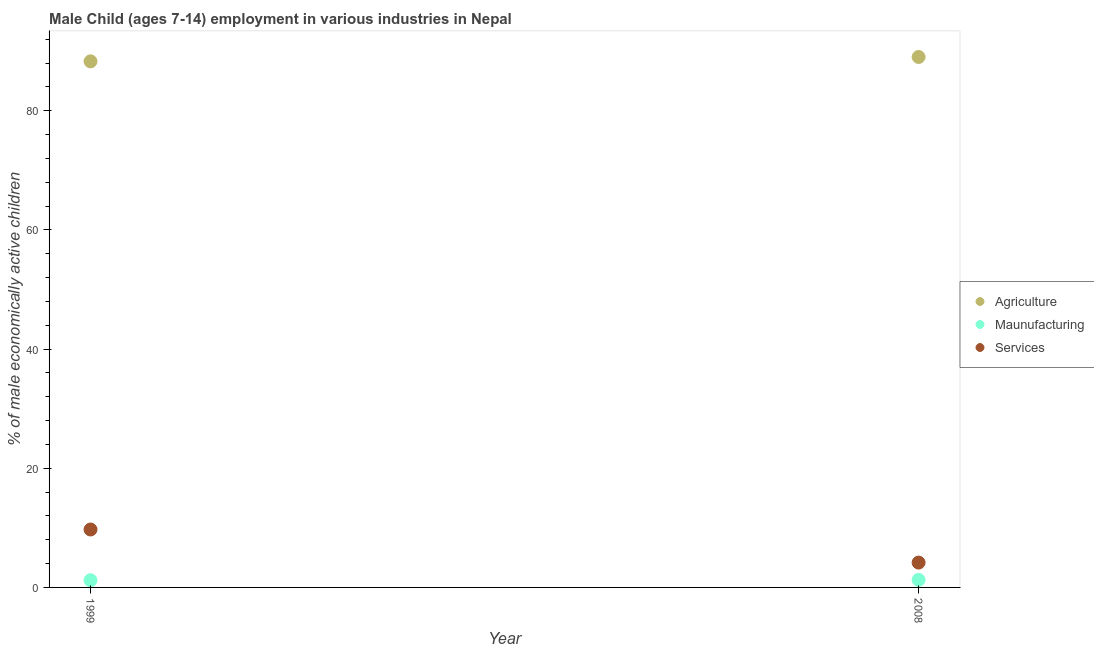Is the number of dotlines equal to the number of legend labels?
Offer a very short reply. Yes. What is the percentage of economically active children in manufacturing in 1999?
Give a very brief answer. 1.2. Across all years, what is the maximum percentage of economically active children in manufacturing?
Ensure brevity in your answer.  1.27. Across all years, what is the minimum percentage of economically active children in agriculture?
Offer a terse response. 88.3. In which year was the percentage of economically active children in agriculture minimum?
Provide a succinct answer. 1999. What is the total percentage of economically active children in manufacturing in the graph?
Your answer should be compact. 2.47. What is the difference between the percentage of economically active children in manufacturing in 1999 and that in 2008?
Give a very brief answer. -0.07. What is the difference between the percentage of economically active children in manufacturing in 1999 and the percentage of economically active children in agriculture in 2008?
Provide a succinct answer. -87.83. What is the average percentage of economically active children in manufacturing per year?
Give a very brief answer. 1.24. In the year 2008, what is the difference between the percentage of economically active children in agriculture and percentage of economically active children in services?
Offer a very short reply. 84.86. In how many years, is the percentage of economically active children in agriculture greater than 88 %?
Offer a terse response. 2. What is the ratio of the percentage of economically active children in services in 1999 to that in 2008?
Offer a very short reply. 2.33. Is the percentage of economically active children in services in 1999 less than that in 2008?
Provide a short and direct response. No. In how many years, is the percentage of economically active children in agriculture greater than the average percentage of economically active children in agriculture taken over all years?
Offer a terse response. 1. Is it the case that in every year, the sum of the percentage of economically active children in agriculture and percentage of economically active children in manufacturing is greater than the percentage of economically active children in services?
Your response must be concise. Yes. Does the percentage of economically active children in services monotonically increase over the years?
Provide a short and direct response. No. Is the percentage of economically active children in services strictly less than the percentage of economically active children in manufacturing over the years?
Provide a short and direct response. No. How many years are there in the graph?
Offer a terse response. 2. What is the difference between two consecutive major ticks on the Y-axis?
Offer a terse response. 20. Are the values on the major ticks of Y-axis written in scientific E-notation?
Your response must be concise. No. Does the graph contain any zero values?
Provide a succinct answer. No. What is the title of the graph?
Provide a succinct answer. Male Child (ages 7-14) employment in various industries in Nepal. What is the label or title of the X-axis?
Your answer should be very brief. Year. What is the label or title of the Y-axis?
Keep it short and to the point. % of male economically active children. What is the % of male economically active children in Agriculture in 1999?
Keep it short and to the point. 88.3. What is the % of male economically active children in Maunufacturing in 1999?
Give a very brief answer. 1.2. What is the % of male economically active children in Services in 1999?
Provide a succinct answer. 9.72. What is the % of male economically active children of Agriculture in 2008?
Keep it short and to the point. 89.03. What is the % of male economically active children of Maunufacturing in 2008?
Your answer should be compact. 1.27. What is the % of male economically active children of Services in 2008?
Provide a short and direct response. 4.17. Across all years, what is the maximum % of male economically active children of Agriculture?
Your answer should be compact. 89.03. Across all years, what is the maximum % of male economically active children in Maunufacturing?
Offer a terse response. 1.27. Across all years, what is the maximum % of male economically active children in Services?
Offer a terse response. 9.72. Across all years, what is the minimum % of male economically active children in Agriculture?
Ensure brevity in your answer.  88.3. Across all years, what is the minimum % of male economically active children of Maunufacturing?
Give a very brief answer. 1.2. Across all years, what is the minimum % of male economically active children in Services?
Provide a short and direct response. 4.17. What is the total % of male economically active children of Agriculture in the graph?
Keep it short and to the point. 177.33. What is the total % of male economically active children of Maunufacturing in the graph?
Give a very brief answer. 2.47. What is the total % of male economically active children in Services in the graph?
Make the answer very short. 13.89. What is the difference between the % of male economically active children in Agriculture in 1999 and that in 2008?
Ensure brevity in your answer.  -0.73. What is the difference between the % of male economically active children in Maunufacturing in 1999 and that in 2008?
Ensure brevity in your answer.  -0.07. What is the difference between the % of male economically active children in Services in 1999 and that in 2008?
Give a very brief answer. 5.55. What is the difference between the % of male economically active children in Agriculture in 1999 and the % of male economically active children in Maunufacturing in 2008?
Offer a terse response. 87.03. What is the difference between the % of male economically active children in Agriculture in 1999 and the % of male economically active children in Services in 2008?
Give a very brief answer. 84.13. What is the difference between the % of male economically active children of Maunufacturing in 1999 and the % of male economically active children of Services in 2008?
Make the answer very short. -2.97. What is the average % of male economically active children of Agriculture per year?
Give a very brief answer. 88.67. What is the average % of male economically active children of Maunufacturing per year?
Make the answer very short. 1.24. What is the average % of male economically active children of Services per year?
Provide a short and direct response. 6.95. In the year 1999, what is the difference between the % of male economically active children of Agriculture and % of male economically active children of Maunufacturing?
Your response must be concise. 87.1. In the year 1999, what is the difference between the % of male economically active children in Agriculture and % of male economically active children in Services?
Make the answer very short. 78.58. In the year 1999, what is the difference between the % of male economically active children of Maunufacturing and % of male economically active children of Services?
Provide a succinct answer. -8.52. In the year 2008, what is the difference between the % of male economically active children in Agriculture and % of male economically active children in Maunufacturing?
Give a very brief answer. 87.76. In the year 2008, what is the difference between the % of male economically active children in Agriculture and % of male economically active children in Services?
Your answer should be compact. 84.86. What is the ratio of the % of male economically active children of Maunufacturing in 1999 to that in 2008?
Your answer should be very brief. 0.95. What is the ratio of the % of male economically active children in Services in 1999 to that in 2008?
Provide a succinct answer. 2.33. What is the difference between the highest and the second highest % of male economically active children in Agriculture?
Provide a succinct answer. 0.73. What is the difference between the highest and the second highest % of male economically active children of Maunufacturing?
Your answer should be compact. 0.07. What is the difference between the highest and the second highest % of male economically active children of Services?
Provide a succinct answer. 5.55. What is the difference between the highest and the lowest % of male economically active children in Agriculture?
Your answer should be compact. 0.73. What is the difference between the highest and the lowest % of male economically active children in Maunufacturing?
Offer a terse response. 0.07. What is the difference between the highest and the lowest % of male economically active children in Services?
Provide a short and direct response. 5.55. 